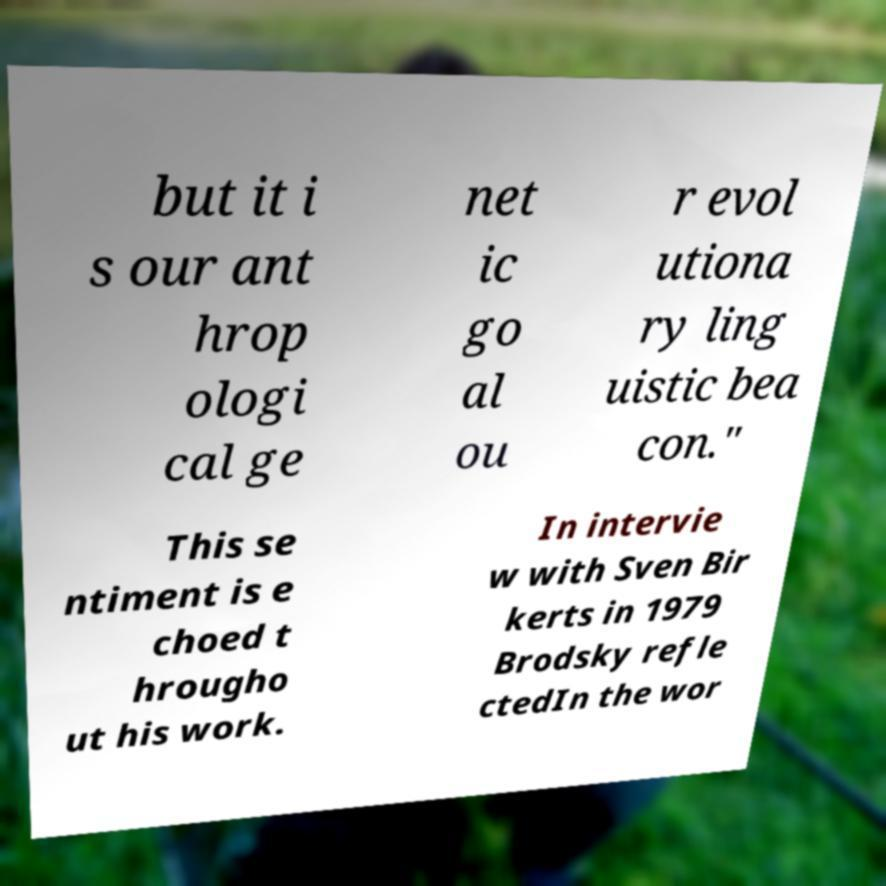Please read and relay the text visible in this image. What does it say? but it i s our ant hrop ologi cal ge net ic go al ou r evol utiona ry ling uistic bea con." This se ntiment is e choed t hrougho ut his work. In intervie w with Sven Bir kerts in 1979 Brodsky refle ctedIn the wor 